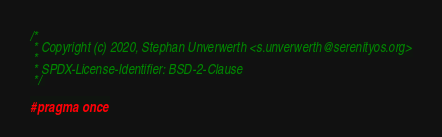<code> <loc_0><loc_0><loc_500><loc_500><_C_>/*
 * Copyright (c) 2020, Stephan Unverwerth <s.unverwerth@serenityos.org>
 *
 * SPDX-License-Identifier: BSD-2-Clause
 */

#pragma once
</code> 